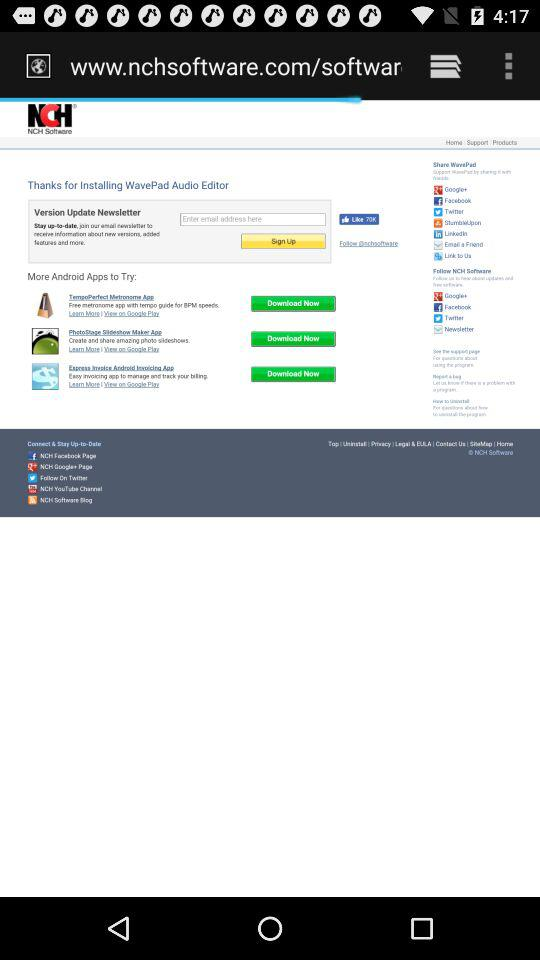What's the total number of likes? The total number of likes is 70K. 